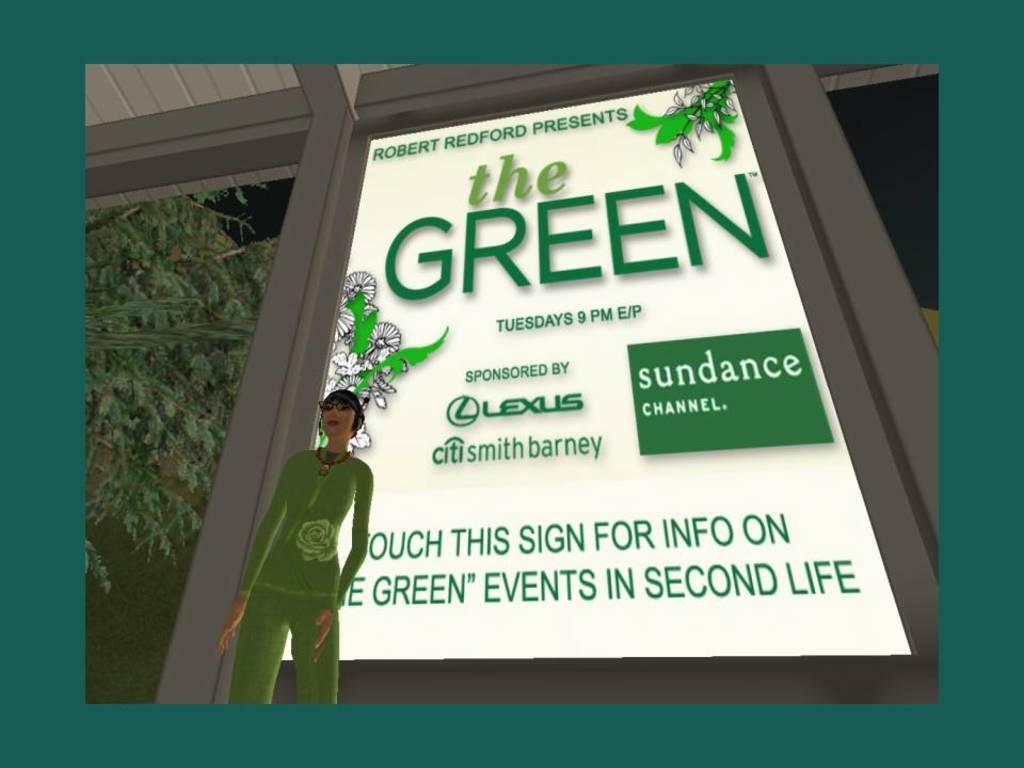What type of poster is featured in the image? There is an animated poster of a girl in the image. What is the girl in the poster wearing? The girl is wearing a green dress. What color is the advertising poster in the image? The advertising poster is white. What can be seen on the left side of the image? There is a tree on the left side of the image. Can you tell me how many grains of sand are visible on the girl's dress in the image? There are no grains of sand visible on the girl's dress in the image. Is there a library in the background of the image? There is no library present in the image. 